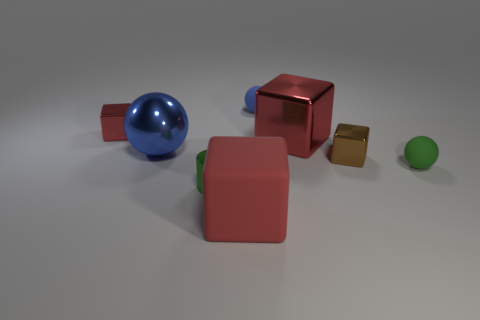Subtract all blue cylinders. How many red cubes are left? 3 Subtract 1 blocks. How many blocks are left? 3 Subtract all red cylinders. Subtract all brown blocks. How many cylinders are left? 1 Add 1 small blocks. How many objects exist? 9 Subtract all spheres. How many objects are left? 5 Add 4 small metal blocks. How many small metal blocks are left? 6 Add 7 green matte things. How many green matte things exist? 8 Subtract 0 brown cylinders. How many objects are left? 8 Subtract all small purple rubber cylinders. Subtract all matte balls. How many objects are left? 6 